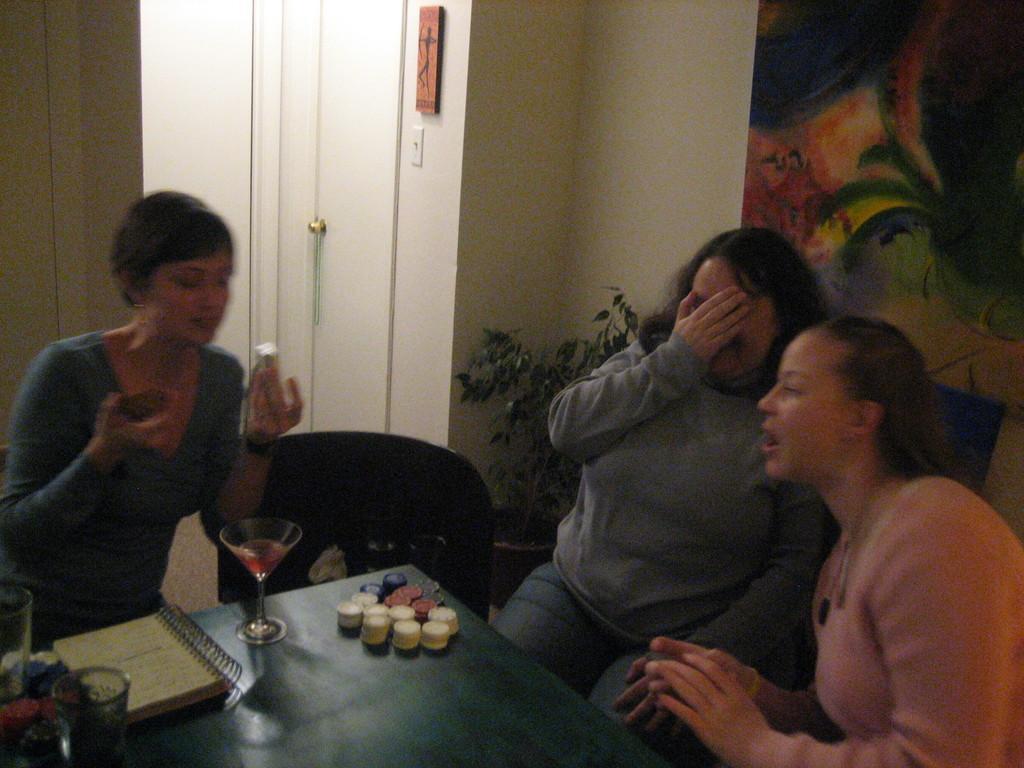Could you give a brief overview of what you see in this image? This picture is clicked inside a room. There are few people sitting on chairs at the table. On the table there are coins, glasses and a dairy. Beside to them there is a houseplant. To the right corner there is frame hanging on the wall. In the background there is wall. 